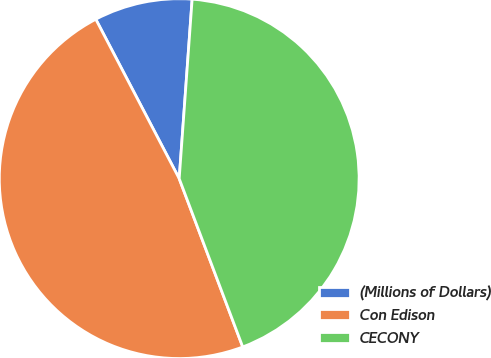Convert chart. <chart><loc_0><loc_0><loc_500><loc_500><pie_chart><fcel>(Millions of Dollars)<fcel>Con Edison<fcel>CECONY<nl><fcel>8.82%<fcel>48.07%<fcel>43.11%<nl></chart> 